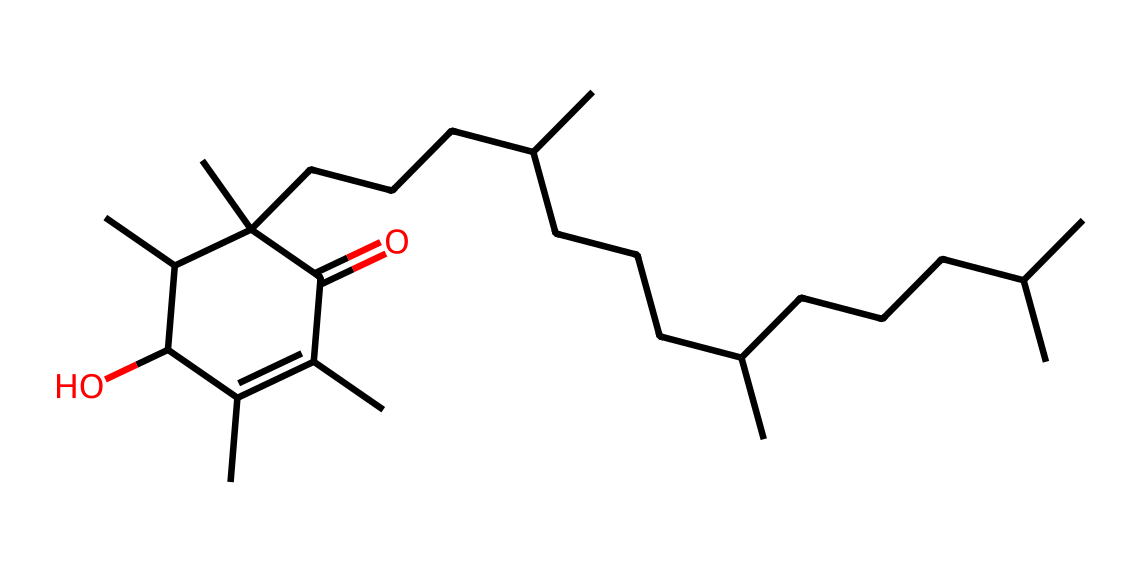What is the molecular weight of vitamin E represented by the provided SMILES? To determine the molecular weight, we need to count the various atoms in the structure represented by the SMILES. The molecule contains carbon, hydrogen, and oxygen atoms. There are 20 carbon atoms, 38 hydrogen atoms, and 1 oxygen atom. By calculating the molecular weight using the standard atomic weights (C=12.01 g/mol, H=1.01 g/mol, O=16.00 g/mol), we get: (20 * 12.01) + (38 * 1.01) + (1 * 16.00) = 268.31 g/mol.
Answer: 268.31 g/mol How many double bonds are present in vitamin E? To find the number of double bonds, we need to inspect the structure represented in the SMILES notation. Double bonds are typically denoted in the SMILES by '=' signs. In this structure, there are two occurrences of double bonds, denoted directly.
Answer: 2 What functional group is indicated by the presence of the hydroxyl (–OH) group in vitamin E? The hydroxyl group (–OH) is a characteristic feature of alcohols. It contributes to the hydrophilicity of the vitamin E molecule and plays a crucial role in its antioxidant properties. In this molecular structure, the OH group is found on the ring structure.
Answer: alcohol What is the total number of ring structures in vitamin E? Looking at the SMILES representation, the molecule has a single cyclic part described by the 'C1' and 'C' which signifies the formation of a cyclic structure. There is only one ring in this particular structure of vitamin E.
Answer: 1 What is the type of vitamin E as per its general classification? Vitamin E is classified as a tocopherol, which is a type of fat-soluble vitamin. This classification arises from the specific molecular structure and functional groups that define its properties and biological roles.
Answer: tocopherol 